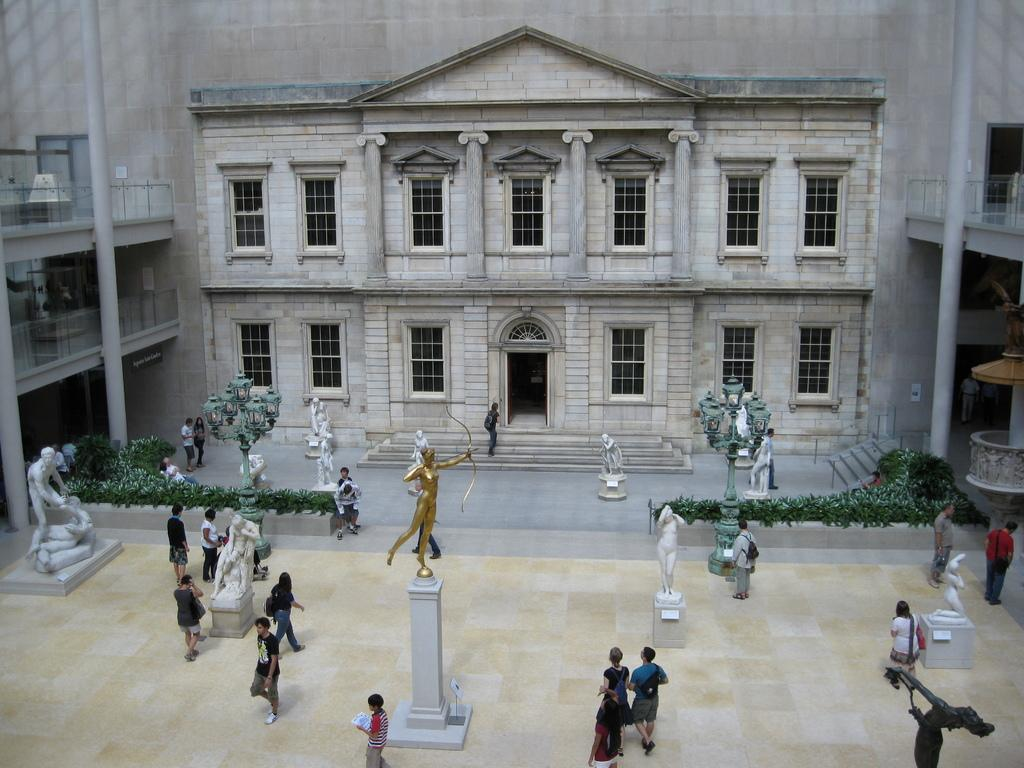What are the people in the image doing? The people in the image are walking. Where are the people walking in relation to the building? The people are walking in front of a building. What other objects or structures can be seen in the image? There are statues, trees, and a lamp post in the image. What type of religious ceremony is taking place in the image? There is no indication of a religious ceremony in the image; it simply shows people walking in front of a building. Can you tell me how many gloves are visible in the image? There are no gloves present in the image. 